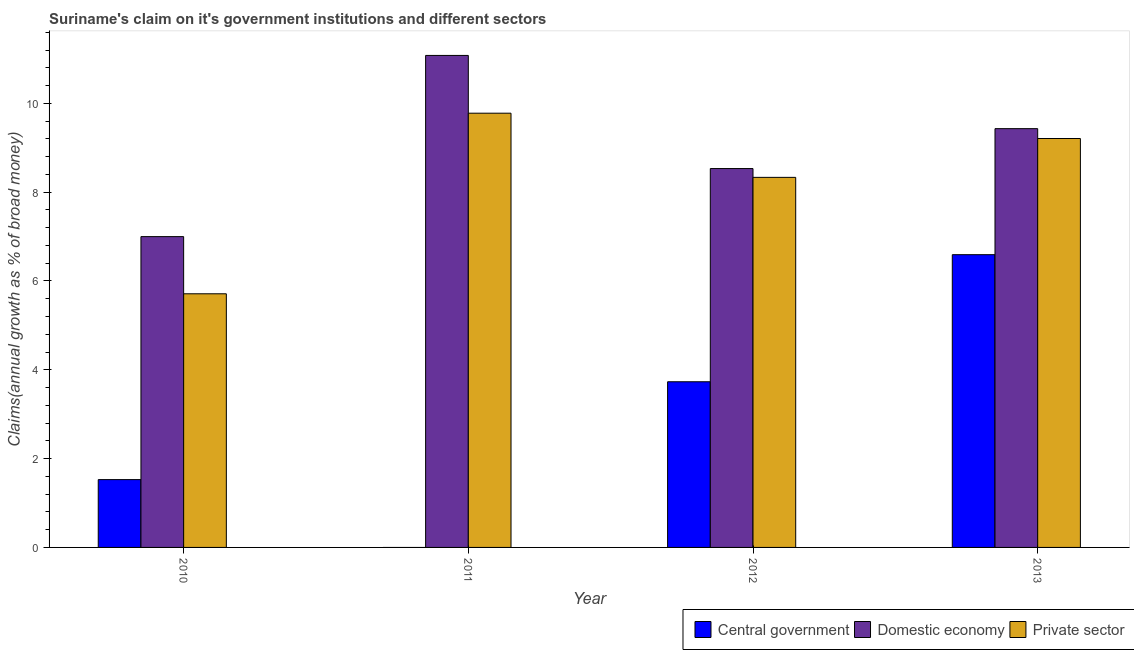How many different coloured bars are there?
Your answer should be compact. 3. How many groups of bars are there?
Give a very brief answer. 4. Are the number of bars on each tick of the X-axis equal?
Your response must be concise. No. What is the label of the 2nd group of bars from the left?
Make the answer very short. 2011. What is the percentage of claim on the domestic economy in 2010?
Provide a short and direct response. 7. Across all years, what is the maximum percentage of claim on the central government?
Provide a short and direct response. 6.59. Across all years, what is the minimum percentage of claim on the domestic economy?
Give a very brief answer. 7. In which year was the percentage of claim on the central government maximum?
Keep it short and to the point. 2013. What is the total percentage of claim on the private sector in the graph?
Give a very brief answer. 33.03. What is the difference between the percentage of claim on the private sector in 2011 and that in 2012?
Your answer should be compact. 1.44. What is the difference between the percentage of claim on the domestic economy in 2013 and the percentage of claim on the private sector in 2012?
Ensure brevity in your answer.  0.9. What is the average percentage of claim on the central government per year?
Ensure brevity in your answer.  2.96. In how many years, is the percentage of claim on the domestic economy greater than 2.4 %?
Provide a short and direct response. 4. What is the ratio of the percentage of claim on the private sector in 2010 to that in 2013?
Offer a very short reply. 0.62. Is the percentage of claim on the domestic economy in 2011 less than that in 2013?
Keep it short and to the point. No. Is the difference between the percentage of claim on the domestic economy in 2011 and 2012 greater than the difference between the percentage of claim on the central government in 2011 and 2012?
Provide a succinct answer. No. What is the difference between the highest and the second highest percentage of claim on the domestic economy?
Provide a succinct answer. 1.65. What is the difference between the highest and the lowest percentage of claim on the domestic economy?
Make the answer very short. 4.08. Is it the case that in every year, the sum of the percentage of claim on the central government and percentage of claim on the domestic economy is greater than the percentage of claim on the private sector?
Provide a short and direct response. Yes. Are all the bars in the graph horizontal?
Ensure brevity in your answer.  No. How many years are there in the graph?
Offer a very short reply. 4. What is the difference between two consecutive major ticks on the Y-axis?
Make the answer very short. 2. Does the graph contain any zero values?
Keep it short and to the point. Yes. Does the graph contain grids?
Keep it short and to the point. No. Where does the legend appear in the graph?
Offer a very short reply. Bottom right. How are the legend labels stacked?
Ensure brevity in your answer.  Horizontal. What is the title of the graph?
Offer a terse response. Suriname's claim on it's government institutions and different sectors. Does "Oil" appear as one of the legend labels in the graph?
Make the answer very short. No. What is the label or title of the X-axis?
Ensure brevity in your answer.  Year. What is the label or title of the Y-axis?
Offer a very short reply. Claims(annual growth as % of broad money). What is the Claims(annual growth as % of broad money) of Central government in 2010?
Your answer should be compact. 1.53. What is the Claims(annual growth as % of broad money) of Domestic economy in 2010?
Provide a succinct answer. 7. What is the Claims(annual growth as % of broad money) in Private sector in 2010?
Provide a short and direct response. 5.71. What is the Claims(annual growth as % of broad money) of Central government in 2011?
Keep it short and to the point. 0. What is the Claims(annual growth as % of broad money) in Domestic economy in 2011?
Provide a succinct answer. 11.08. What is the Claims(annual growth as % of broad money) in Private sector in 2011?
Give a very brief answer. 9.78. What is the Claims(annual growth as % of broad money) of Central government in 2012?
Provide a short and direct response. 3.73. What is the Claims(annual growth as % of broad money) in Domestic economy in 2012?
Ensure brevity in your answer.  8.53. What is the Claims(annual growth as % of broad money) in Private sector in 2012?
Give a very brief answer. 8.33. What is the Claims(annual growth as % of broad money) of Central government in 2013?
Your response must be concise. 6.59. What is the Claims(annual growth as % of broad money) of Domestic economy in 2013?
Offer a terse response. 9.43. What is the Claims(annual growth as % of broad money) of Private sector in 2013?
Give a very brief answer. 9.21. Across all years, what is the maximum Claims(annual growth as % of broad money) of Central government?
Offer a terse response. 6.59. Across all years, what is the maximum Claims(annual growth as % of broad money) in Domestic economy?
Offer a very short reply. 11.08. Across all years, what is the maximum Claims(annual growth as % of broad money) of Private sector?
Your answer should be compact. 9.78. Across all years, what is the minimum Claims(annual growth as % of broad money) of Domestic economy?
Give a very brief answer. 7. Across all years, what is the minimum Claims(annual growth as % of broad money) of Private sector?
Offer a terse response. 5.71. What is the total Claims(annual growth as % of broad money) of Central government in the graph?
Ensure brevity in your answer.  11.85. What is the total Claims(annual growth as % of broad money) of Domestic economy in the graph?
Ensure brevity in your answer.  36.04. What is the total Claims(annual growth as % of broad money) in Private sector in the graph?
Give a very brief answer. 33.03. What is the difference between the Claims(annual growth as % of broad money) of Domestic economy in 2010 and that in 2011?
Ensure brevity in your answer.  -4.08. What is the difference between the Claims(annual growth as % of broad money) of Private sector in 2010 and that in 2011?
Give a very brief answer. -4.07. What is the difference between the Claims(annual growth as % of broad money) in Central government in 2010 and that in 2012?
Your answer should be compact. -2.2. What is the difference between the Claims(annual growth as % of broad money) in Domestic economy in 2010 and that in 2012?
Offer a terse response. -1.53. What is the difference between the Claims(annual growth as % of broad money) of Private sector in 2010 and that in 2012?
Offer a very short reply. -2.62. What is the difference between the Claims(annual growth as % of broad money) in Central government in 2010 and that in 2013?
Give a very brief answer. -5.06. What is the difference between the Claims(annual growth as % of broad money) in Domestic economy in 2010 and that in 2013?
Offer a very short reply. -2.43. What is the difference between the Claims(annual growth as % of broad money) of Private sector in 2010 and that in 2013?
Your response must be concise. -3.5. What is the difference between the Claims(annual growth as % of broad money) in Domestic economy in 2011 and that in 2012?
Your answer should be very brief. 2.55. What is the difference between the Claims(annual growth as % of broad money) in Private sector in 2011 and that in 2012?
Offer a very short reply. 1.44. What is the difference between the Claims(annual growth as % of broad money) of Domestic economy in 2011 and that in 2013?
Ensure brevity in your answer.  1.65. What is the difference between the Claims(annual growth as % of broad money) in Private sector in 2011 and that in 2013?
Your answer should be compact. 0.57. What is the difference between the Claims(annual growth as % of broad money) of Central government in 2012 and that in 2013?
Ensure brevity in your answer.  -2.86. What is the difference between the Claims(annual growth as % of broad money) in Domestic economy in 2012 and that in 2013?
Ensure brevity in your answer.  -0.9. What is the difference between the Claims(annual growth as % of broad money) of Private sector in 2012 and that in 2013?
Keep it short and to the point. -0.87. What is the difference between the Claims(annual growth as % of broad money) of Central government in 2010 and the Claims(annual growth as % of broad money) of Domestic economy in 2011?
Offer a terse response. -9.55. What is the difference between the Claims(annual growth as % of broad money) in Central government in 2010 and the Claims(annual growth as % of broad money) in Private sector in 2011?
Make the answer very short. -8.25. What is the difference between the Claims(annual growth as % of broad money) in Domestic economy in 2010 and the Claims(annual growth as % of broad money) in Private sector in 2011?
Ensure brevity in your answer.  -2.78. What is the difference between the Claims(annual growth as % of broad money) in Central government in 2010 and the Claims(annual growth as % of broad money) in Domestic economy in 2012?
Your answer should be very brief. -7. What is the difference between the Claims(annual growth as % of broad money) in Central government in 2010 and the Claims(annual growth as % of broad money) in Private sector in 2012?
Keep it short and to the point. -6.81. What is the difference between the Claims(annual growth as % of broad money) in Domestic economy in 2010 and the Claims(annual growth as % of broad money) in Private sector in 2012?
Ensure brevity in your answer.  -1.33. What is the difference between the Claims(annual growth as % of broad money) of Central government in 2010 and the Claims(annual growth as % of broad money) of Domestic economy in 2013?
Ensure brevity in your answer.  -7.9. What is the difference between the Claims(annual growth as % of broad money) of Central government in 2010 and the Claims(annual growth as % of broad money) of Private sector in 2013?
Your answer should be very brief. -7.68. What is the difference between the Claims(annual growth as % of broad money) of Domestic economy in 2010 and the Claims(annual growth as % of broad money) of Private sector in 2013?
Provide a succinct answer. -2.21. What is the difference between the Claims(annual growth as % of broad money) in Domestic economy in 2011 and the Claims(annual growth as % of broad money) in Private sector in 2012?
Ensure brevity in your answer.  2.75. What is the difference between the Claims(annual growth as % of broad money) of Domestic economy in 2011 and the Claims(annual growth as % of broad money) of Private sector in 2013?
Provide a succinct answer. 1.87. What is the difference between the Claims(annual growth as % of broad money) in Central government in 2012 and the Claims(annual growth as % of broad money) in Domestic economy in 2013?
Your answer should be compact. -5.7. What is the difference between the Claims(annual growth as % of broad money) in Central government in 2012 and the Claims(annual growth as % of broad money) in Private sector in 2013?
Your response must be concise. -5.48. What is the difference between the Claims(annual growth as % of broad money) of Domestic economy in 2012 and the Claims(annual growth as % of broad money) of Private sector in 2013?
Ensure brevity in your answer.  -0.68. What is the average Claims(annual growth as % of broad money) of Central government per year?
Provide a succinct answer. 2.96. What is the average Claims(annual growth as % of broad money) of Domestic economy per year?
Your answer should be very brief. 9.01. What is the average Claims(annual growth as % of broad money) in Private sector per year?
Provide a short and direct response. 8.26. In the year 2010, what is the difference between the Claims(annual growth as % of broad money) of Central government and Claims(annual growth as % of broad money) of Domestic economy?
Offer a very short reply. -5.47. In the year 2010, what is the difference between the Claims(annual growth as % of broad money) in Central government and Claims(annual growth as % of broad money) in Private sector?
Offer a very short reply. -4.18. In the year 2010, what is the difference between the Claims(annual growth as % of broad money) in Domestic economy and Claims(annual growth as % of broad money) in Private sector?
Keep it short and to the point. 1.29. In the year 2011, what is the difference between the Claims(annual growth as % of broad money) of Domestic economy and Claims(annual growth as % of broad money) of Private sector?
Provide a short and direct response. 1.3. In the year 2012, what is the difference between the Claims(annual growth as % of broad money) of Central government and Claims(annual growth as % of broad money) of Domestic economy?
Provide a short and direct response. -4.8. In the year 2012, what is the difference between the Claims(annual growth as % of broad money) of Central government and Claims(annual growth as % of broad money) of Private sector?
Ensure brevity in your answer.  -4.6. In the year 2012, what is the difference between the Claims(annual growth as % of broad money) of Domestic economy and Claims(annual growth as % of broad money) of Private sector?
Provide a succinct answer. 0.2. In the year 2013, what is the difference between the Claims(annual growth as % of broad money) of Central government and Claims(annual growth as % of broad money) of Domestic economy?
Offer a terse response. -2.84. In the year 2013, what is the difference between the Claims(annual growth as % of broad money) in Central government and Claims(annual growth as % of broad money) in Private sector?
Provide a short and direct response. -2.62. In the year 2013, what is the difference between the Claims(annual growth as % of broad money) of Domestic economy and Claims(annual growth as % of broad money) of Private sector?
Keep it short and to the point. 0.22. What is the ratio of the Claims(annual growth as % of broad money) of Domestic economy in 2010 to that in 2011?
Provide a succinct answer. 0.63. What is the ratio of the Claims(annual growth as % of broad money) of Private sector in 2010 to that in 2011?
Your answer should be very brief. 0.58. What is the ratio of the Claims(annual growth as % of broad money) of Central government in 2010 to that in 2012?
Your response must be concise. 0.41. What is the ratio of the Claims(annual growth as % of broad money) of Domestic economy in 2010 to that in 2012?
Offer a terse response. 0.82. What is the ratio of the Claims(annual growth as % of broad money) of Private sector in 2010 to that in 2012?
Offer a terse response. 0.69. What is the ratio of the Claims(annual growth as % of broad money) of Central government in 2010 to that in 2013?
Your answer should be compact. 0.23. What is the ratio of the Claims(annual growth as % of broad money) of Domestic economy in 2010 to that in 2013?
Provide a succinct answer. 0.74. What is the ratio of the Claims(annual growth as % of broad money) in Private sector in 2010 to that in 2013?
Your answer should be compact. 0.62. What is the ratio of the Claims(annual growth as % of broad money) in Domestic economy in 2011 to that in 2012?
Make the answer very short. 1.3. What is the ratio of the Claims(annual growth as % of broad money) in Private sector in 2011 to that in 2012?
Your response must be concise. 1.17. What is the ratio of the Claims(annual growth as % of broad money) of Domestic economy in 2011 to that in 2013?
Offer a terse response. 1.17. What is the ratio of the Claims(annual growth as % of broad money) in Private sector in 2011 to that in 2013?
Give a very brief answer. 1.06. What is the ratio of the Claims(annual growth as % of broad money) in Central government in 2012 to that in 2013?
Provide a short and direct response. 0.57. What is the ratio of the Claims(annual growth as % of broad money) of Domestic economy in 2012 to that in 2013?
Your answer should be very brief. 0.9. What is the ratio of the Claims(annual growth as % of broad money) in Private sector in 2012 to that in 2013?
Offer a very short reply. 0.91. What is the difference between the highest and the second highest Claims(annual growth as % of broad money) in Central government?
Your response must be concise. 2.86. What is the difference between the highest and the second highest Claims(annual growth as % of broad money) of Domestic economy?
Your answer should be very brief. 1.65. What is the difference between the highest and the second highest Claims(annual growth as % of broad money) of Private sector?
Ensure brevity in your answer.  0.57. What is the difference between the highest and the lowest Claims(annual growth as % of broad money) of Central government?
Provide a succinct answer. 6.59. What is the difference between the highest and the lowest Claims(annual growth as % of broad money) of Domestic economy?
Provide a short and direct response. 4.08. What is the difference between the highest and the lowest Claims(annual growth as % of broad money) of Private sector?
Give a very brief answer. 4.07. 